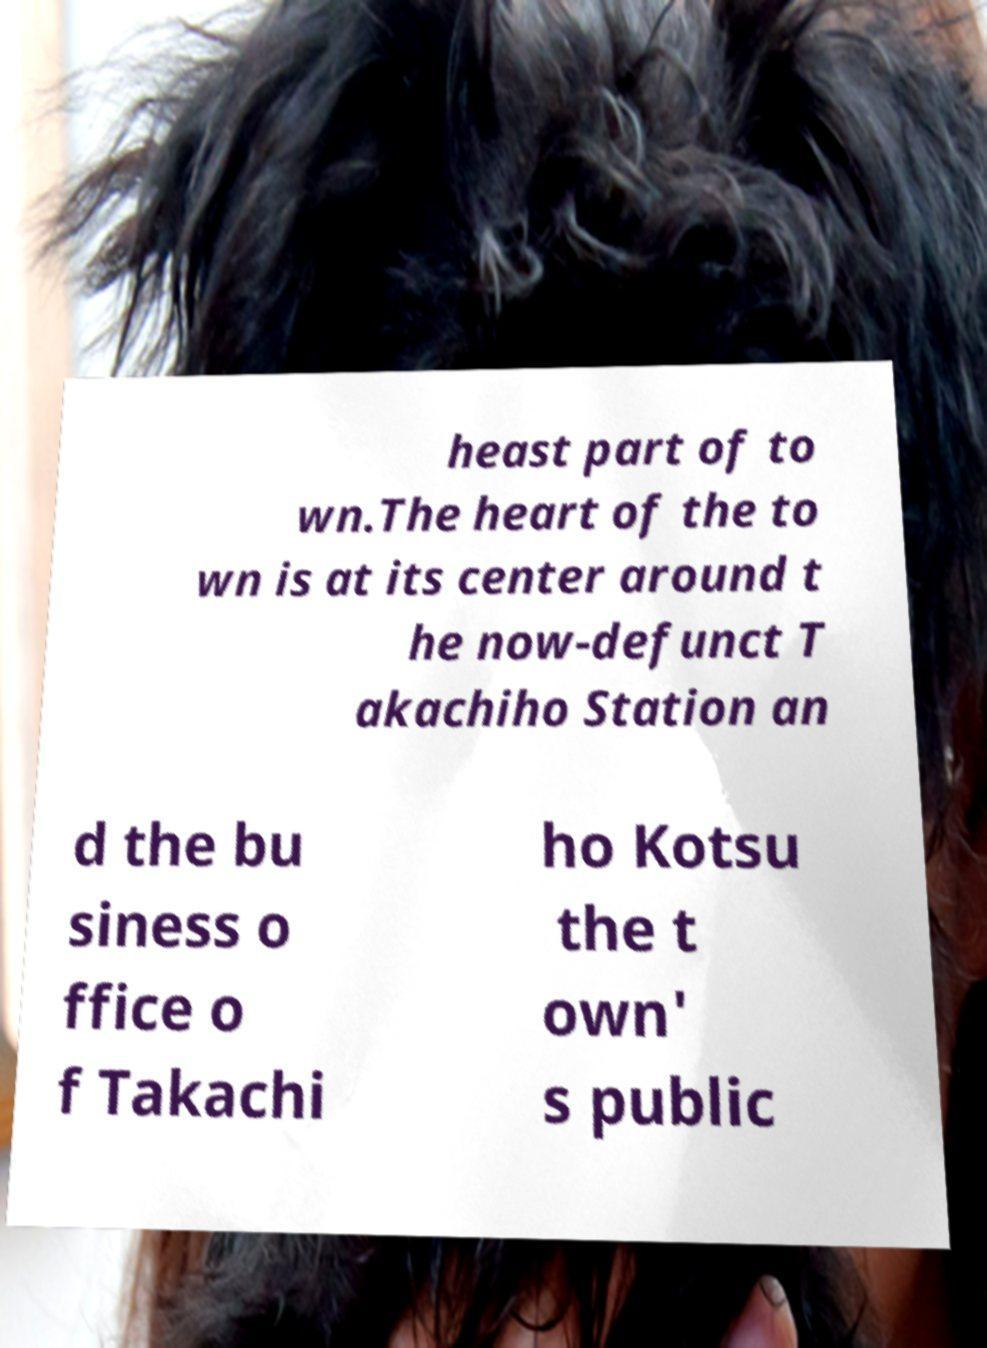Please read and relay the text visible in this image. What does it say? heast part of to wn.The heart of the to wn is at its center around t he now-defunct T akachiho Station an d the bu siness o ffice o f Takachi ho Kotsu the t own' s public 